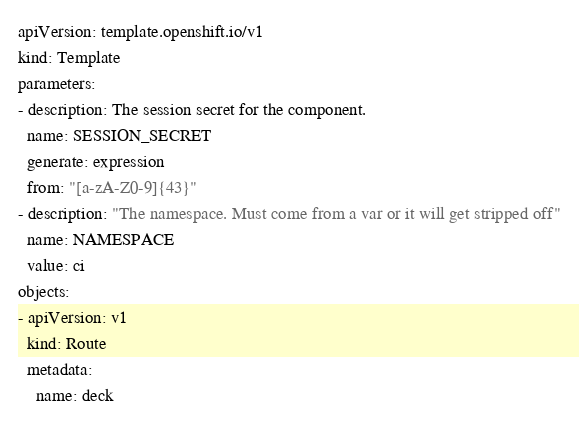<code> <loc_0><loc_0><loc_500><loc_500><_YAML_>apiVersion: template.openshift.io/v1
kind: Template
parameters:
- description: The session secret for the component.
  name: SESSION_SECRET
  generate: expression
  from: "[a-zA-Z0-9]{43}"
- description: "The namespace. Must come from a var or it will get stripped off"
  name: NAMESPACE
  value: ci
objects:
- apiVersion: v1
  kind: Route
  metadata:
    name: deck</code> 